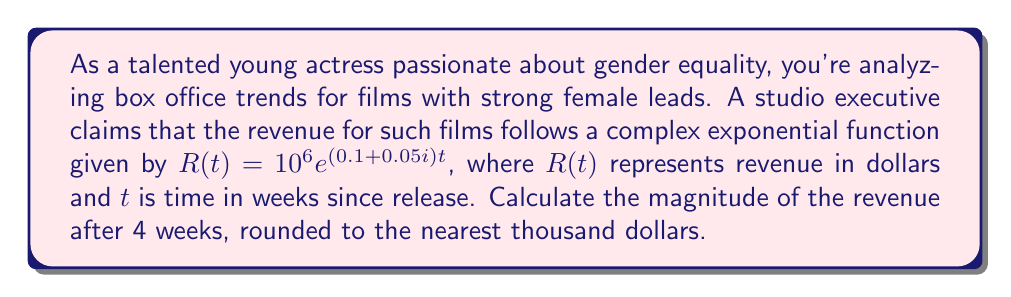Show me your answer to this math problem. To solve this problem, we'll follow these steps:

1) The given complex exponential function is:
   $R(t) = 10^6 e^{(0.1 + 0.05i)t}$

2) We need to find $|R(4)|$, which is the magnitude of $R(t)$ when $t = 4$.

3) Substituting $t = 4$ into the function:
   $R(4) = 10^6 e^{(0.1 + 0.05i)4} = 10^6 e^{0.4 + 0.2i}$

4) To find the magnitude, we use the property $|e^{a+bi}| = e^a$:
   $|R(4)| = |10^6 e^{0.4 + 0.2i}| = 10^6 |e^{0.4 + 0.2i}| = 10^6 e^{0.4}$

5) Calculate $e^{0.4}$:
   $e^{0.4} \approx 1.4918$

6) Multiply by $10^6$:
   $10^6 e^{0.4} \approx 1,491,800$

7) Rounding to the nearest thousand:
   $1,492,000$

This result shows that after 4 weeks, the magnitude of the revenue for films with strong female leads is expected to be about $1,492,000, according to the given model.
Answer: $1,492,000 